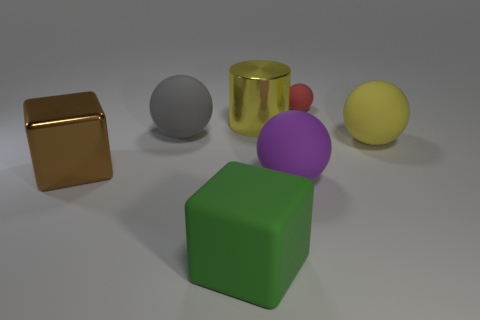Is there a matte thing that has the same color as the cylinder?
Your response must be concise. Yes. There is a thing behind the shiny cylinder; what is its shape?
Offer a very short reply. Sphere. There is a big matte object to the right of the small red thing; is it the same color as the large cylinder?
Your answer should be very brief. Yes. Are there fewer rubber blocks right of the small matte object than gray rubber balls?
Offer a terse response. Yes. What is the color of the big block that is the same material as the big purple thing?
Offer a terse response. Green. What size is the block on the right side of the large brown metal object?
Keep it short and to the point. Large. Do the tiny red sphere and the yellow cylinder have the same material?
Make the answer very short. No. Are there any yellow objects that are in front of the large sphere that is on the left side of the big rubber sphere in front of the large brown metal block?
Your answer should be compact. Yes. What color is the shiny cylinder?
Ensure brevity in your answer.  Yellow. The metallic block that is the same size as the cylinder is what color?
Your answer should be very brief. Brown. 